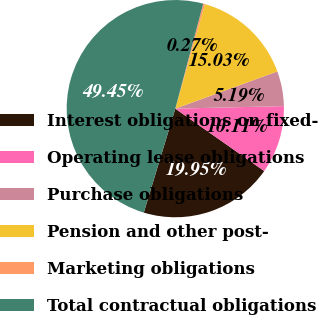Convert chart. <chart><loc_0><loc_0><loc_500><loc_500><pie_chart><fcel>Interest obligations on fixed-<fcel>Operating lease obligations<fcel>Purchase obligations<fcel>Pension and other post-<fcel>Marketing obligations<fcel>Total contractual obligations<nl><fcel>19.95%<fcel>10.11%<fcel>5.19%<fcel>15.03%<fcel>0.27%<fcel>49.45%<nl></chart> 